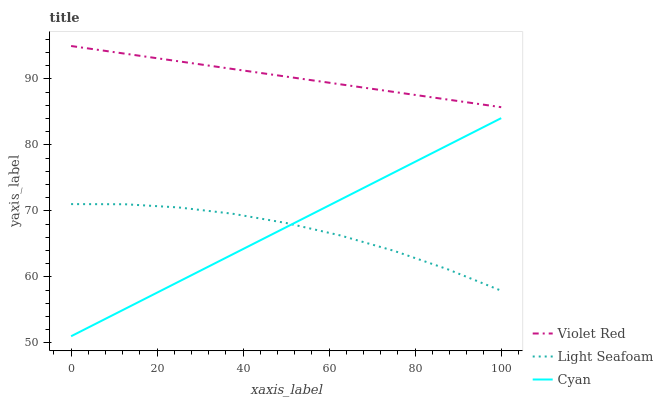Does Light Seafoam have the minimum area under the curve?
Answer yes or no. Yes. Does Violet Red have the maximum area under the curve?
Answer yes or no. Yes. Does Violet Red have the minimum area under the curve?
Answer yes or no. No. Does Light Seafoam have the maximum area under the curve?
Answer yes or no. No. Is Cyan the smoothest?
Answer yes or no. Yes. Is Light Seafoam the roughest?
Answer yes or no. Yes. Is Violet Red the smoothest?
Answer yes or no. No. Is Violet Red the roughest?
Answer yes or no. No. Does Cyan have the lowest value?
Answer yes or no. Yes. Does Light Seafoam have the lowest value?
Answer yes or no. No. Does Violet Red have the highest value?
Answer yes or no. Yes. Does Light Seafoam have the highest value?
Answer yes or no. No. Is Light Seafoam less than Violet Red?
Answer yes or no. Yes. Is Violet Red greater than Light Seafoam?
Answer yes or no. Yes. Does Cyan intersect Light Seafoam?
Answer yes or no. Yes. Is Cyan less than Light Seafoam?
Answer yes or no. No. Is Cyan greater than Light Seafoam?
Answer yes or no. No. Does Light Seafoam intersect Violet Red?
Answer yes or no. No. 